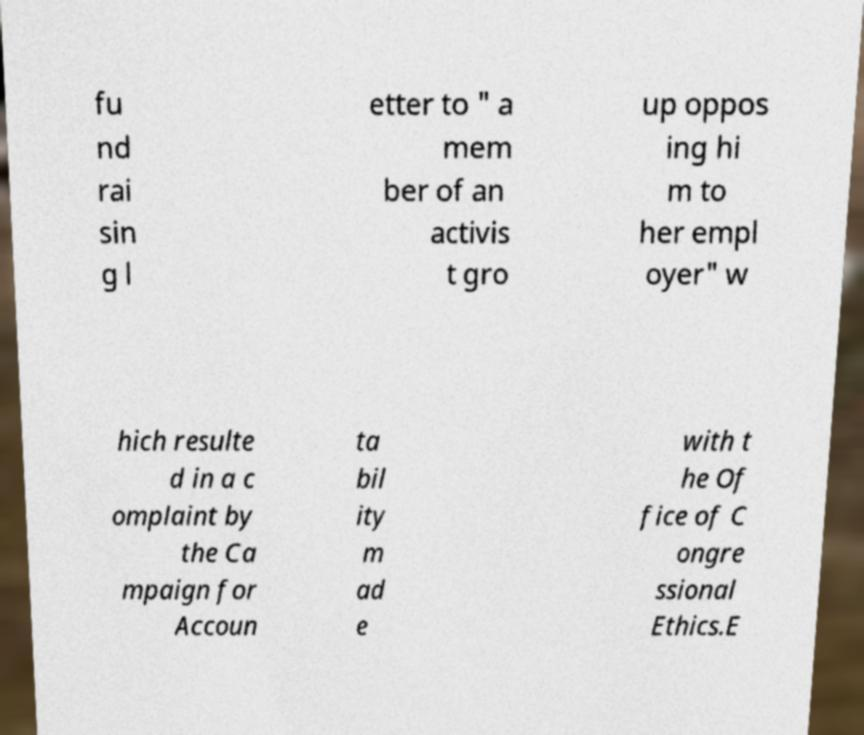There's text embedded in this image that I need extracted. Can you transcribe it verbatim? fu nd rai sin g l etter to " a mem ber of an activis t gro up oppos ing hi m to her empl oyer" w hich resulte d in a c omplaint by the Ca mpaign for Accoun ta bil ity m ad e with t he Of fice of C ongre ssional Ethics.E 